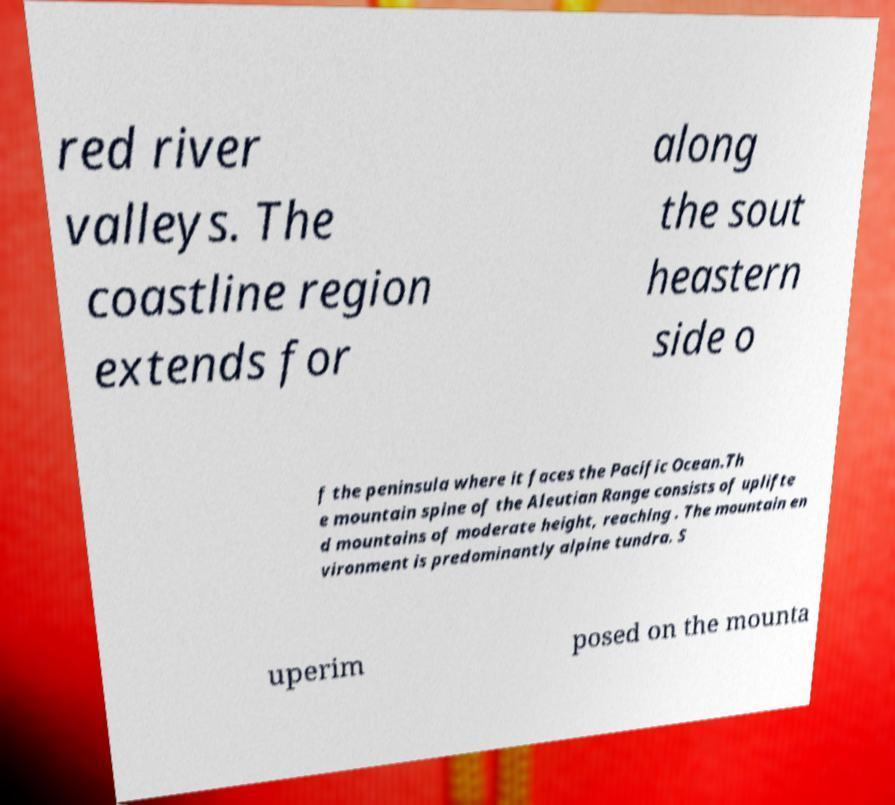Please identify and transcribe the text found in this image. red river valleys. The coastline region extends for along the sout heastern side o f the peninsula where it faces the Pacific Ocean.Th e mountain spine of the Aleutian Range consists of uplifte d mountains of moderate height, reaching . The mountain en vironment is predominantly alpine tundra. S uperim posed on the mounta 